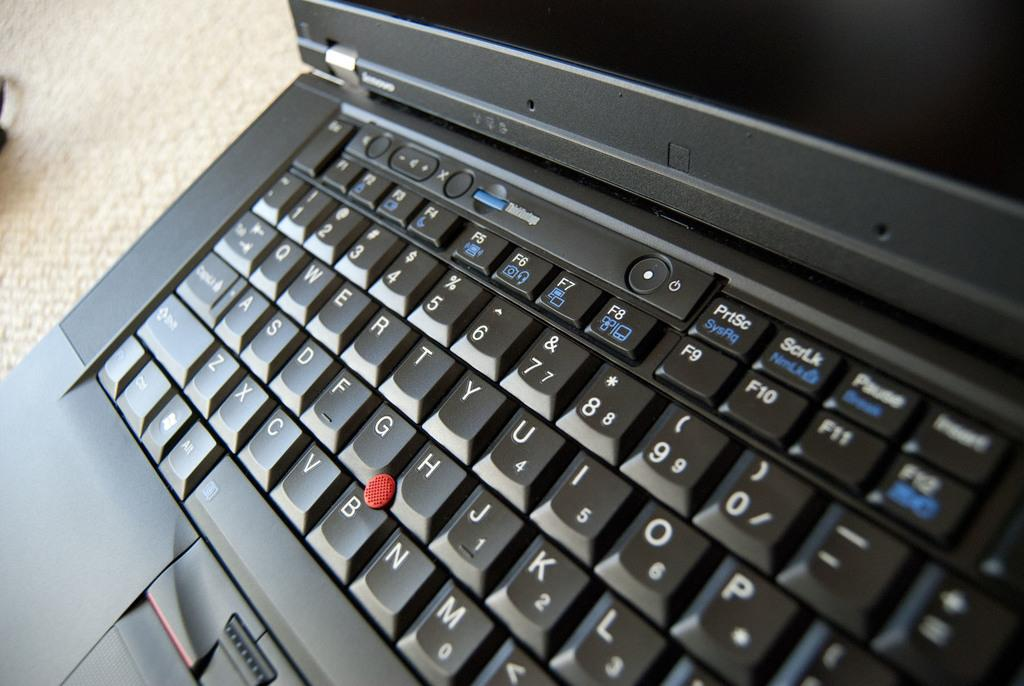What type of electronic device is visible in the image? There is a black color laptop in the image. What is the primary input device for the laptop? There is a keypad in the image. What type of holiday is being celebrated in the image? There is no indication of a holiday being celebrated in the image, as it only features a black color laptop and a keypad. 